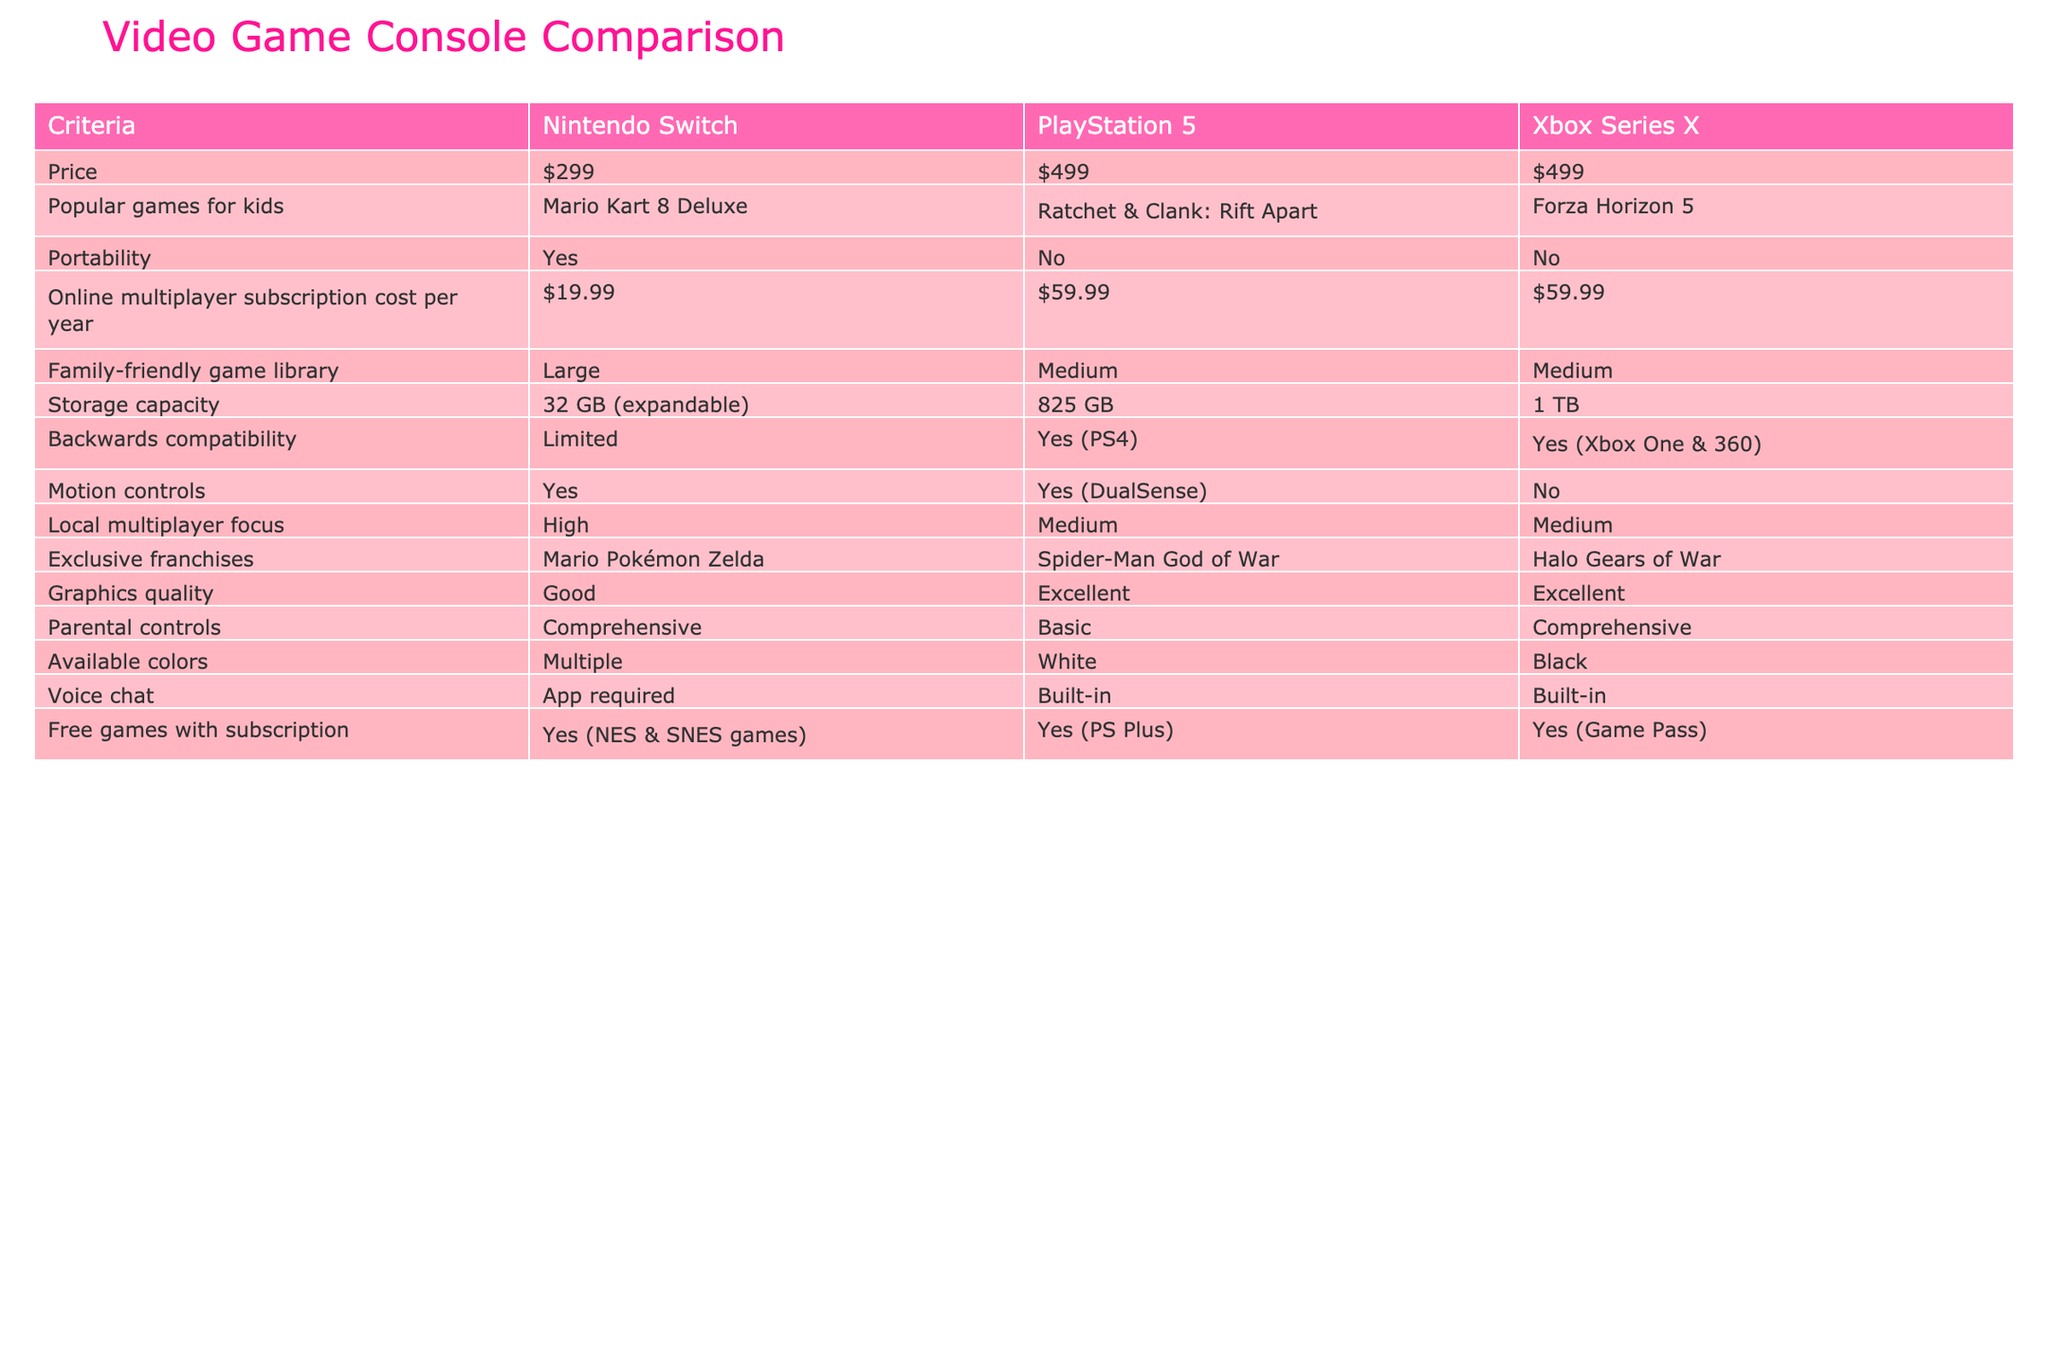What is the price of the Nintendo Switch? The price of the Nintendo Switch is listed directly in the table under the "Price" column. It shows $299 as the cost.
Answer: $299 Which console has a larger storage capacity, PlayStation 5 or Xbox Series X? The storage capacity for the PlayStation 5 is listed as 825 GB, while the Xbox Series X has a storage capacity of 1 TB. Since 1 TB is greater than 825 GB, the Xbox Series X has a larger capacity.
Answer: Xbox Series X Is there a free game subscription available with the Nintendo Switch? The table indicates that the Nintendo Switch offers free games with a subscription, specifically NES & SNES games. So the answer is yes.
Answer: Yes Does the Nintendo Switch have a built-in voice chat feature? The table states that the Nintendo Switch requires an app for voice chat, while both the PlayStation 5 and Xbox Series X have built-in voice chat. Therefore, the answer is no for the Nintendo Switch.
Answer: No Which console has the most family-friendly game library, and how is it categorized? The Nintendo Switch has a "Large" family-friendly game library, while both the PlayStation 5 and Xbox Series X have a "Medium" categorization. This is determined by comparing the values in the "Family-friendly game library" column.
Answer: Nintendo Switch How much more does the PlayStation 5 cost compared to the Nintendo Switch? The PlayStation 5 is $499, and the Nintendo Switch is $299. To find the difference, subtract $299 from $499, which equals $200.
Answer: $200 Is the Xbox Series X portable? The table specifies "No" under the "Portability" criteria for the Xbox Series X, indicating it is not designed to be portable.
Answer: No Which console has comprehensive parental controls, and what does this imply? Both the Nintendo Switch and Xbox Series X have comprehensive parental controls, while the PlayStation 5 only has basic controls. This implies that the Nintendo Switch and Xbox Series X provide more features for parents to monitor and regulate gameplay.
Answer: Nintendo Switch and Xbox Series X What is the total annual cost of online multiplayer subscriptions for both PlayStation 5 and Xbox Series X? The annual subscription cost for the PlayStation 5 is $59.99 and for the Xbox Series X is also $59.99. To find the total, add these two amounts together: $59.99 + $59.99 = $119.98.
Answer: $119.98 